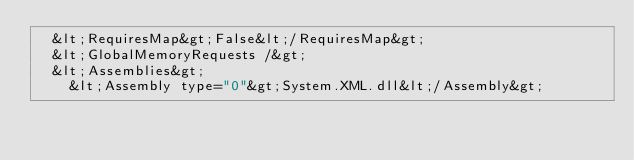<code> <loc_0><loc_0><loc_500><loc_500><_XML_>  &lt;RequiresMap&gt;False&lt;/RequiresMap&gt;
  &lt;GlobalMemoryRequests /&gt;
  &lt;Assemblies&gt;
    &lt;Assembly type="0"&gt;System.XML.dll&lt;/Assembly&gt;</code> 